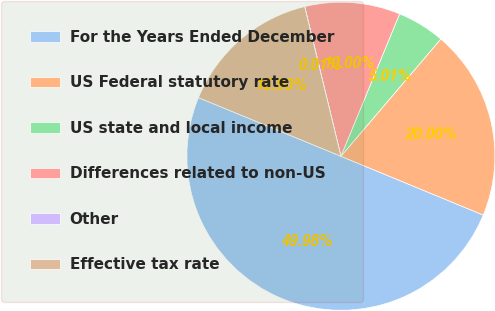<chart> <loc_0><loc_0><loc_500><loc_500><pie_chart><fcel>For the Years Ended December<fcel>US Federal statutory rate<fcel>US state and local income<fcel>Differences related to non-US<fcel>Other<fcel>Effective tax rate<nl><fcel>49.98%<fcel>20.0%<fcel>5.01%<fcel>10.0%<fcel>0.01%<fcel>15.0%<nl></chart> 